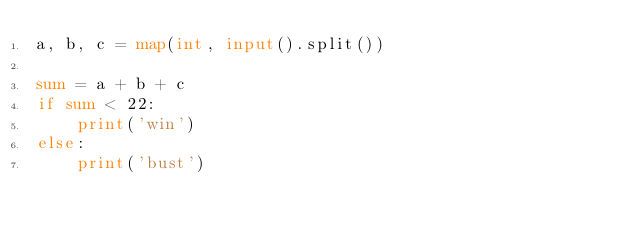<code> <loc_0><loc_0><loc_500><loc_500><_Python_>a, b, c = map(int, input().split())

sum = a + b + c
if sum < 22:
    print('win')
else:
    print('bust')</code> 